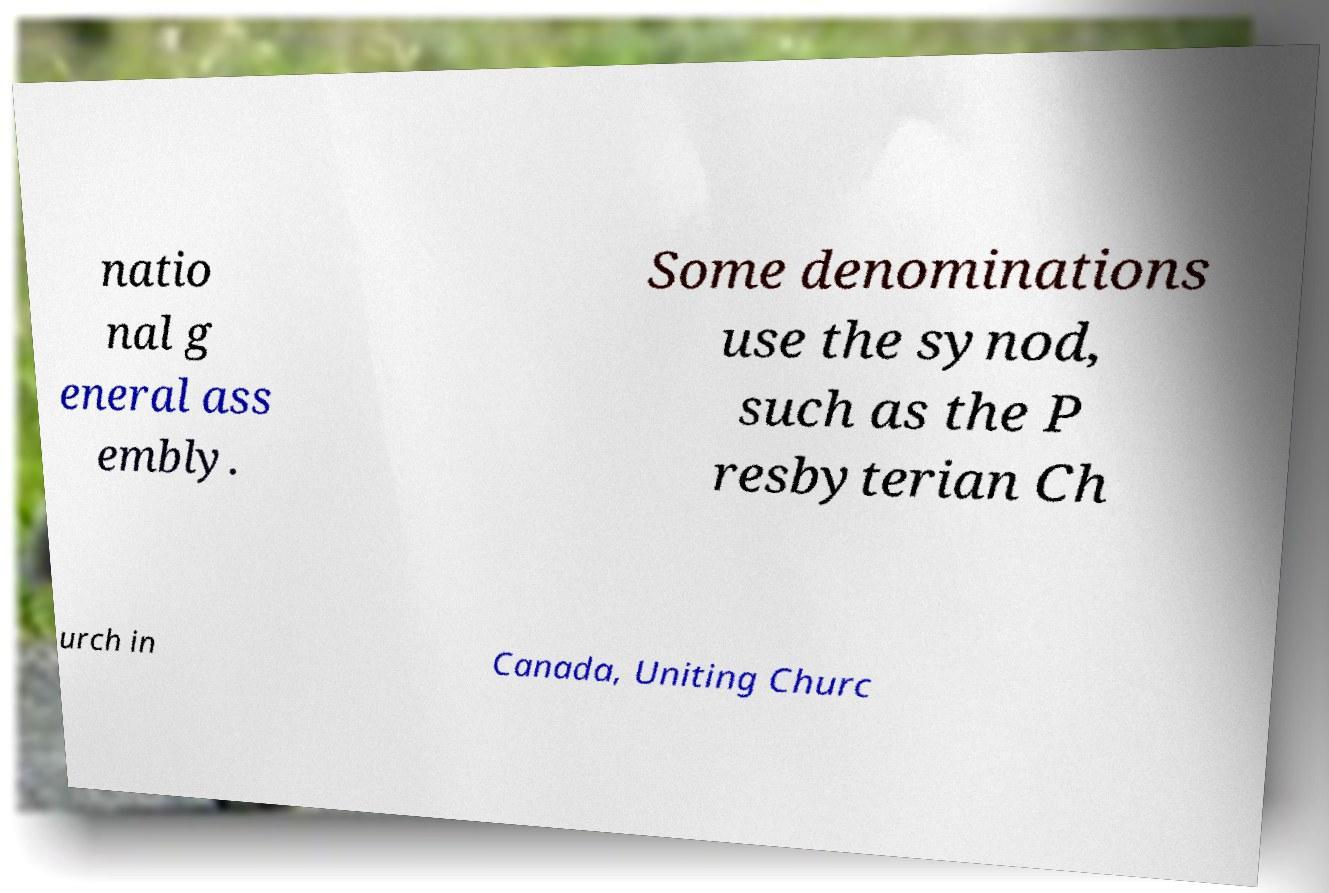Please identify and transcribe the text found in this image. natio nal g eneral ass embly. Some denominations use the synod, such as the P resbyterian Ch urch in Canada, Uniting Churc 